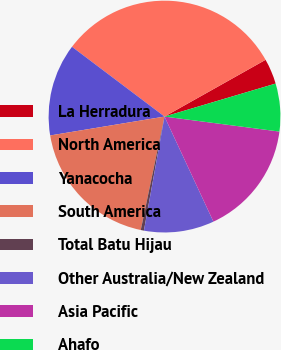Convert chart to OTSL. <chart><loc_0><loc_0><loc_500><loc_500><pie_chart><fcel>La Herradura<fcel>North America<fcel>Yanacocha<fcel>South America<fcel>Total Batu Hijau<fcel>Other Australia/New Zealand<fcel>Asia Pacific<fcel>Ahafo<nl><fcel>3.55%<fcel>31.57%<fcel>12.89%<fcel>19.11%<fcel>0.44%<fcel>9.78%<fcel>16.0%<fcel>6.66%<nl></chart> 